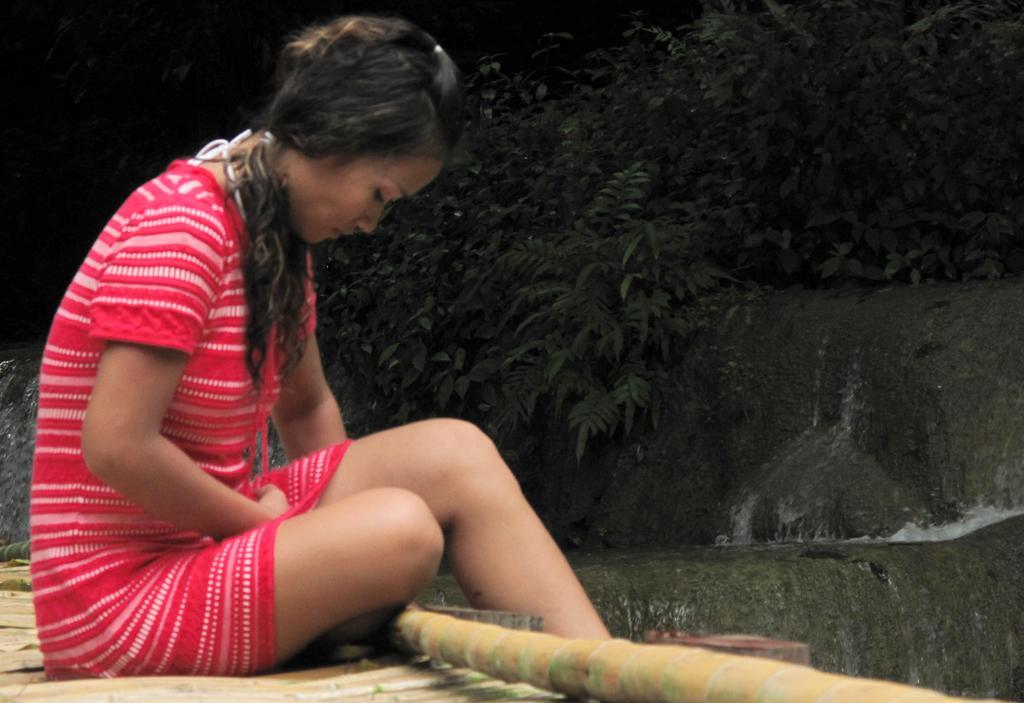In one or two sentences, can you explain what this image depicts? In this picture I can see a woman, who is wearing pink and red color dress and I see that, she is sitting. In the background I can see the leaves and on the right side of this picture I can see the water. 